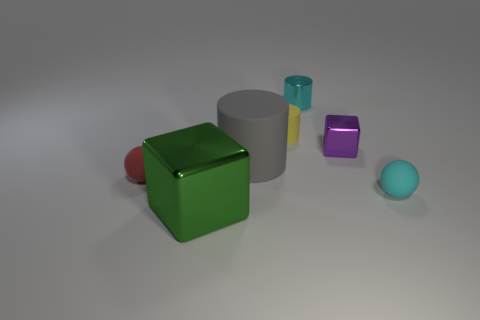Add 2 large matte things. How many objects exist? 9 Subtract all balls. How many objects are left? 5 Add 5 gray objects. How many gray objects are left? 6 Add 6 tiny yellow matte cylinders. How many tiny yellow matte cylinders exist? 7 Subtract 1 green blocks. How many objects are left? 6 Subtract all large green shiny blocks. Subtract all small cyan cylinders. How many objects are left? 5 